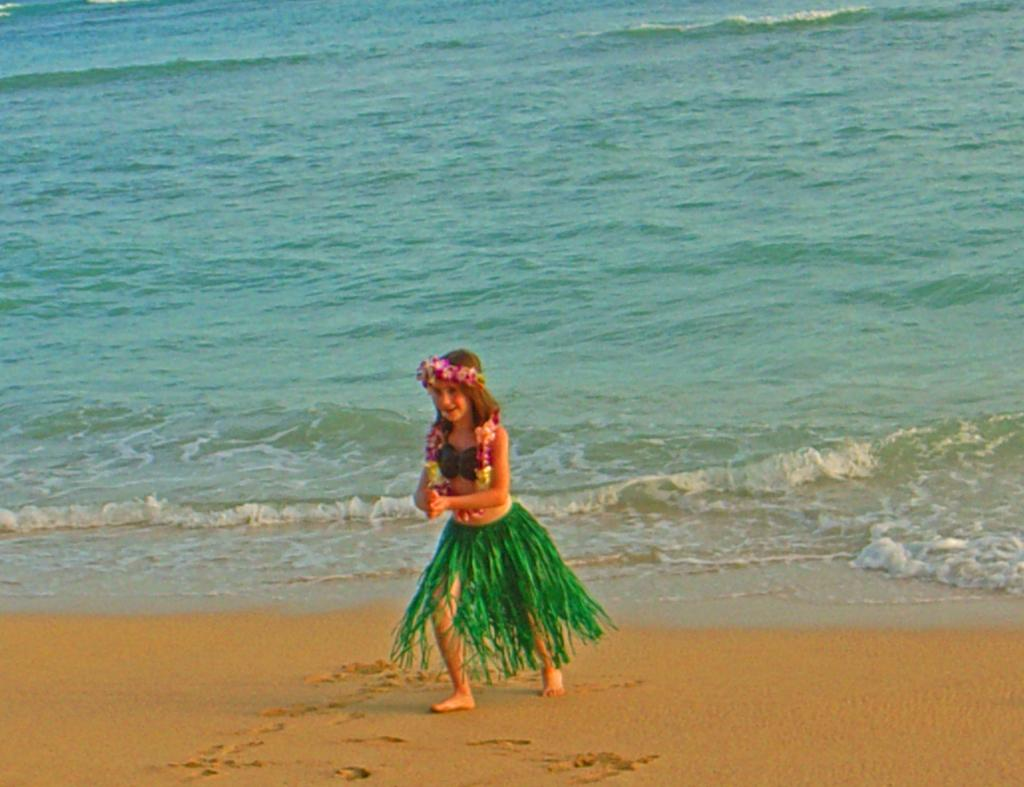What type of terrain is visible in the image? There is water and sand visible in the image. What is the girl in the image doing? The girl is walking in the image. What type of reward is the girl receiving for walking in the image? There is no indication in the image that the girl is receiving a reward for walking. What type of oil can be seen in the image? There is no oil present in the image. 